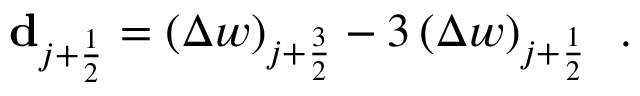Convert formula to latex. <formula><loc_0><loc_0><loc_500><loc_500>{ d _ { j + \frac { 1 } { 2 } } = \left ( \Delta w \right ) _ { j + \frac { 3 } { 2 } } - 3 \left ( \Delta w \right ) _ { j + \frac { 1 } { 2 } } \, . }</formula> 